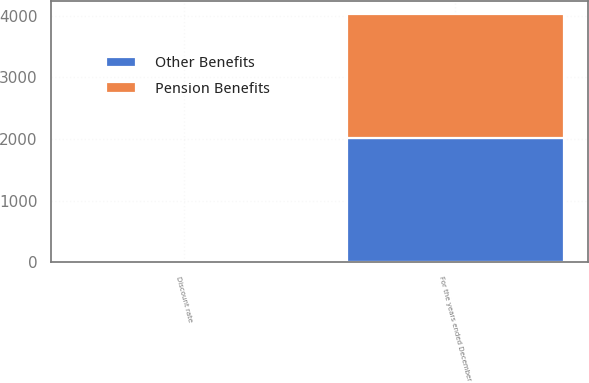Convert chart. <chart><loc_0><loc_0><loc_500><loc_500><stacked_bar_chart><ecel><fcel>For the years ended December<fcel>Discount rate<nl><fcel>Other Benefits<fcel>2015<fcel>3.7<nl><fcel>Pension Benefits<fcel>2015<fcel>3.7<nl></chart> 